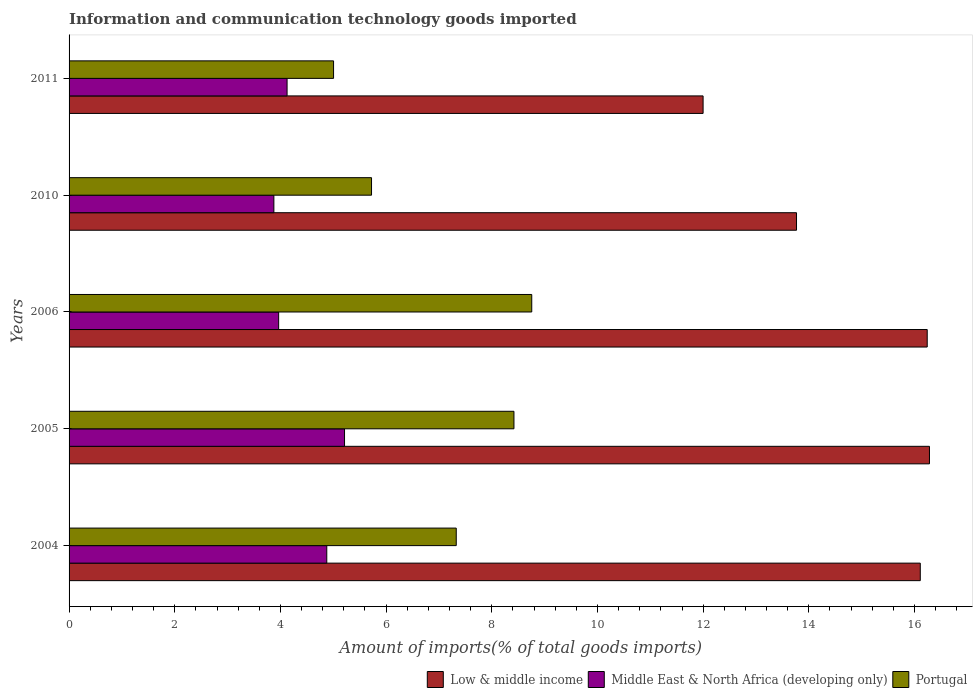How many bars are there on the 2nd tick from the top?
Your response must be concise. 3. In how many cases, is the number of bars for a given year not equal to the number of legend labels?
Your response must be concise. 0. What is the amount of goods imported in Middle East & North Africa (developing only) in 2010?
Provide a succinct answer. 3.88. Across all years, what is the maximum amount of goods imported in Middle East & North Africa (developing only)?
Your response must be concise. 5.21. Across all years, what is the minimum amount of goods imported in Portugal?
Provide a succinct answer. 5.01. In which year was the amount of goods imported in Low & middle income minimum?
Ensure brevity in your answer.  2011. What is the total amount of goods imported in Low & middle income in the graph?
Give a very brief answer. 74.4. What is the difference between the amount of goods imported in Low & middle income in 2010 and that in 2011?
Make the answer very short. 1.77. What is the difference between the amount of goods imported in Middle East & North Africa (developing only) in 2004 and the amount of goods imported in Portugal in 2005?
Keep it short and to the point. -3.54. What is the average amount of goods imported in Low & middle income per year?
Ensure brevity in your answer.  14.88. In the year 2005, what is the difference between the amount of goods imported in Middle East & North Africa (developing only) and amount of goods imported in Low & middle income?
Your response must be concise. -11.07. What is the ratio of the amount of goods imported in Middle East & North Africa (developing only) in 2004 to that in 2005?
Your answer should be compact. 0.94. Is the difference between the amount of goods imported in Middle East & North Africa (developing only) in 2006 and 2010 greater than the difference between the amount of goods imported in Low & middle income in 2006 and 2010?
Provide a succinct answer. No. What is the difference between the highest and the second highest amount of goods imported in Portugal?
Keep it short and to the point. 0.34. What is the difference between the highest and the lowest amount of goods imported in Low & middle income?
Your response must be concise. 4.28. In how many years, is the amount of goods imported in Low & middle income greater than the average amount of goods imported in Low & middle income taken over all years?
Offer a terse response. 3. Is the sum of the amount of goods imported in Portugal in 2004 and 2011 greater than the maximum amount of goods imported in Middle East & North Africa (developing only) across all years?
Make the answer very short. Yes. What does the 3rd bar from the top in 2005 represents?
Your answer should be very brief. Low & middle income. What does the 2nd bar from the bottom in 2010 represents?
Your answer should be very brief. Middle East & North Africa (developing only). How many bars are there?
Give a very brief answer. 15. What is the difference between two consecutive major ticks on the X-axis?
Your response must be concise. 2. Does the graph contain any zero values?
Offer a very short reply. No. How many legend labels are there?
Provide a short and direct response. 3. What is the title of the graph?
Your response must be concise. Information and communication technology goods imported. Does "Channel Islands" appear as one of the legend labels in the graph?
Keep it short and to the point. No. What is the label or title of the X-axis?
Keep it short and to the point. Amount of imports(% of total goods imports). What is the label or title of the Y-axis?
Ensure brevity in your answer.  Years. What is the Amount of imports(% of total goods imports) of Low & middle income in 2004?
Provide a succinct answer. 16.11. What is the Amount of imports(% of total goods imports) in Middle East & North Africa (developing only) in 2004?
Offer a very short reply. 4.88. What is the Amount of imports(% of total goods imports) of Portugal in 2004?
Give a very brief answer. 7.33. What is the Amount of imports(% of total goods imports) in Low & middle income in 2005?
Offer a terse response. 16.28. What is the Amount of imports(% of total goods imports) in Middle East & North Africa (developing only) in 2005?
Your answer should be compact. 5.21. What is the Amount of imports(% of total goods imports) in Portugal in 2005?
Your answer should be very brief. 8.42. What is the Amount of imports(% of total goods imports) in Low & middle income in 2006?
Your response must be concise. 16.24. What is the Amount of imports(% of total goods imports) in Middle East & North Africa (developing only) in 2006?
Offer a very short reply. 3.97. What is the Amount of imports(% of total goods imports) of Portugal in 2006?
Offer a very short reply. 8.76. What is the Amount of imports(% of total goods imports) in Low & middle income in 2010?
Your answer should be very brief. 13.77. What is the Amount of imports(% of total goods imports) of Middle East & North Africa (developing only) in 2010?
Offer a very short reply. 3.88. What is the Amount of imports(% of total goods imports) in Portugal in 2010?
Your answer should be compact. 5.72. What is the Amount of imports(% of total goods imports) in Low & middle income in 2011?
Keep it short and to the point. 12. What is the Amount of imports(% of total goods imports) in Middle East & North Africa (developing only) in 2011?
Keep it short and to the point. 4.13. What is the Amount of imports(% of total goods imports) of Portugal in 2011?
Give a very brief answer. 5.01. Across all years, what is the maximum Amount of imports(% of total goods imports) of Low & middle income?
Your response must be concise. 16.28. Across all years, what is the maximum Amount of imports(% of total goods imports) of Middle East & North Africa (developing only)?
Offer a terse response. 5.21. Across all years, what is the maximum Amount of imports(% of total goods imports) in Portugal?
Provide a short and direct response. 8.76. Across all years, what is the minimum Amount of imports(% of total goods imports) of Low & middle income?
Provide a short and direct response. 12. Across all years, what is the minimum Amount of imports(% of total goods imports) of Middle East & North Africa (developing only)?
Give a very brief answer. 3.88. Across all years, what is the minimum Amount of imports(% of total goods imports) in Portugal?
Provide a short and direct response. 5.01. What is the total Amount of imports(% of total goods imports) of Low & middle income in the graph?
Provide a short and direct response. 74.4. What is the total Amount of imports(% of total goods imports) in Middle East & North Africa (developing only) in the graph?
Provide a succinct answer. 22.06. What is the total Amount of imports(% of total goods imports) of Portugal in the graph?
Offer a very short reply. 35.23. What is the difference between the Amount of imports(% of total goods imports) of Low & middle income in 2004 and that in 2005?
Keep it short and to the point. -0.17. What is the difference between the Amount of imports(% of total goods imports) of Middle East & North Africa (developing only) in 2004 and that in 2005?
Keep it short and to the point. -0.34. What is the difference between the Amount of imports(% of total goods imports) of Portugal in 2004 and that in 2005?
Provide a short and direct response. -1.09. What is the difference between the Amount of imports(% of total goods imports) in Low & middle income in 2004 and that in 2006?
Offer a terse response. -0.13. What is the difference between the Amount of imports(% of total goods imports) in Middle East & North Africa (developing only) in 2004 and that in 2006?
Give a very brief answer. 0.91. What is the difference between the Amount of imports(% of total goods imports) of Portugal in 2004 and that in 2006?
Provide a short and direct response. -1.43. What is the difference between the Amount of imports(% of total goods imports) in Low & middle income in 2004 and that in 2010?
Keep it short and to the point. 2.34. What is the difference between the Amount of imports(% of total goods imports) in Middle East & North Africa (developing only) in 2004 and that in 2010?
Give a very brief answer. 1. What is the difference between the Amount of imports(% of total goods imports) of Portugal in 2004 and that in 2010?
Ensure brevity in your answer.  1.6. What is the difference between the Amount of imports(% of total goods imports) in Low & middle income in 2004 and that in 2011?
Give a very brief answer. 4.11. What is the difference between the Amount of imports(% of total goods imports) of Middle East & North Africa (developing only) in 2004 and that in 2011?
Offer a very short reply. 0.75. What is the difference between the Amount of imports(% of total goods imports) of Portugal in 2004 and that in 2011?
Offer a very short reply. 2.32. What is the difference between the Amount of imports(% of total goods imports) of Low & middle income in 2005 and that in 2006?
Make the answer very short. 0.04. What is the difference between the Amount of imports(% of total goods imports) in Middle East & North Africa (developing only) in 2005 and that in 2006?
Provide a succinct answer. 1.25. What is the difference between the Amount of imports(% of total goods imports) in Portugal in 2005 and that in 2006?
Your answer should be very brief. -0.34. What is the difference between the Amount of imports(% of total goods imports) of Low & middle income in 2005 and that in 2010?
Your response must be concise. 2.52. What is the difference between the Amount of imports(% of total goods imports) in Middle East & North Africa (developing only) in 2005 and that in 2010?
Provide a succinct answer. 1.34. What is the difference between the Amount of imports(% of total goods imports) of Portugal in 2005 and that in 2010?
Your answer should be compact. 2.7. What is the difference between the Amount of imports(% of total goods imports) of Low & middle income in 2005 and that in 2011?
Provide a succinct answer. 4.28. What is the difference between the Amount of imports(% of total goods imports) in Middle East & North Africa (developing only) in 2005 and that in 2011?
Provide a short and direct response. 1.09. What is the difference between the Amount of imports(% of total goods imports) in Portugal in 2005 and that in 2011?
Your response must be concise. 3.41. What is the difference between the Amount of imports(% of total goods imports) of Low & middle income in 2006 and that in 2010?
Your response must be concise. 2.47. What is the difference between the Amount of imports(% of total goods imports) in Middle East & North Africa (developing only) in 2006 and that in 2010?
Make the answer very short. 0.09. What is the difference between the Amount of imports(% of total goods imports) in Portugal in 2006 and that in 2010?
Your answer should be compact. 3.03. What is the difference between the Amount of imports(% of total goods imports) in Low & middle income in 2006 and that in 2011?
Ensure brevity in your answer.  4.24. What is the difference between the Amount of imports(% of total goods imports) of Middle East & North Africa (developing only) in 2006 and that in 2011?
Provide a succinct answer. -0.16. What is the difference between the Amount of imports(% of total goods imports) in Portugal in 2006 and that in 2011?
Offer a very short reply. 3.75. What is the difference between the Amount of imports(% of total goods imports) of Low & middle income in 2010 and that in 2011?
Make the answer very short. 1.77. What is the difference between the Amount of imports(% of total goods imports) of Middle East & North Africa (developing only) in 2010 and that in 2011?
Your answer should be compact. -0.25. What is the difference between the Amount of imports(% of total goods imports) of Portugal in 2010 and that in 2011?
Provide a succinct answer. 0.72. What is the difference between the Amount of imports(% of total goods imports) of Low & middle income in 2004 and the Amount of imports(% of total goods imports) of Middle East & North Africa (developing only) in 2005?
Your answer should be very brief. 10.9. What is the difference between the Amount of imports(% of total goods imports) in Low & middle income in 2004 and the Amount of imports(% of total goods imports) in Portugal in 2005?
Give a very brief answer. 7.69. What is the difference between the Amount of imports(% of total goods imports) in Middle East & North Africa (developing only) in 2004 and the Amount of imports(% of total goods imports) in Portugal in 2005?
Your answer should be very brief. -3.54. What is the difference between the Amount of imports(% of total goods imports) of Low & middle income in 2004 and the Amount of imports(% of total goods imports) of Middle East & North Africa (developing only) in 2006?
Keep it short and to the point. 12.14. What is the difference between the Amount of imports(% of total goods imports) in Low & middle income in 2004 and the Amount of imports(% of total goods imports) in Portugal in 2006?
Your response must be concise. 7.35. What is the difference between the Amount of imports(% of total goods imports) of Middle East & North Africa (developing only) in 2004 and the Amount of imports(% of total goods imports) of Portugal in 2006?
Give a very brief answer. -3.88. What is the difference between the Amount of imports(% of total goods imports) in Low & middle income in 2004 and the Amount of imports(% of total goods imports) in Middle East & North Africa (developing only) in 2010?
Offer a terse response. 12.23. What is the difference between the Amount of imports(% of total goods imports) of Low & middle income in 2004 and the Amount of imports(% of total goods imports) of Portugal in 2010?
Your response must be concise. 10.39. What is the difference between the Amount of imports(% of total goods imports) of Middle East & North Africa (developing only) in 2004 and the Amount of imports(% of total goods imports) of Portugal in 2010?
Ensure brevity in your answer.  -0.85. What is the difference between the Amount of imports(% of total goods imports) of Low & middle income in 2004 and the Amount of imports(% of total goods imports) of Middle East & North Africa (developing only) in 2011?
Your answer should be compact. 11.98. What is the difference between the Amount of imports(% of total goods imports) in Low & middle income in 2004 and the Amount of imports(% of total goods imports) in Portugal in 2011?
Your answer should be very brief. 11.1. What is the difference between the Amount of imports(% of total goods imports) in Middle East & North Africa (developing only) in 2004 and the Amount of imports(% of total goods imports) in Portugal in 2011?
Your response must be concise. -0.13. What is the difference between the Amount of imports(% of total goods imports) in Low & middle income in 2005 and the Amount of imports(% of total goods imports) in Middle East & North Africa (developing only) in 2006?
Your answer should be compact. 12.32. What is the difference between the Amount of imports(% of total goods imports) in Low & middle income in 2005 and the Amount of imports(% of total goods imports) in Portugal in 2006?
Offer a terse response. 7.53. What is the difference between the Amount of imports(% of total goods imports) of Middle East & North Africa (developing only) in 2005 and the Amount of imports(% of total goods imports) of Portugal in 2006?
Offer a terse response. -3.54. What is the difference between the Amount of imports(% of total goods imports) of Low & middle income in 2005 and the Amount of imports(% of total goods imports) of Middle East & North Africa (developing only) in 2010?
Offer a very short reply. 12.41. What is the difference between the Amount of imports(% of total goods imports) of Low & middle income in 2005 and the Amount of imports(% of total goods imports) of Portugal in 2010?
Ensure brevity in your answer.  10.56. What is the difference between the Amount of imports(% of total goods imports) in Middle East & North Africa (developing only) in 2005 and the Amount of imports(% of total goods imports) in Portugal in 2010?
Your response must be concise. -0.51. What is the difference between the Amount of imports(% of total goods imports) in Low & middle income in 2005 and the Amount of imports(% of total goods imports) in Middle East & North Africa (developing only) in 2011?
Offer a very short reply. 12.16. What is the difference between the Amount of imports(% of total goods imports) in Low & middle income in 2005 and the Amount of imports(% of total goods imports) in Portugal in 2011?
Offer a terse response. 11.28. What is the difference between the Amount of imports(% of total goods imports) in Middle East & North Africa (developing only) in 2005 and the Amount of imports(% of total goods imports) in Portugal in 2011?
Keep it short and to the point. 0.21. What is the difference between the Amount of imports(% of total goods imports) of Low & middle income in 2006 and the Amount of imports(% of total goods imports) of Middle East & North Africa (developing only) in 2010?
Give a very brief answer. 12.36. What is the difference between the Amount of imports(% of total goods imports) of Low & middle income in 2006 and the Amount of imports(% of total goods imports) of Portugal in 2010?
Give a very brief answer. 10.52. What is the difference between the Amount of imports(% of total goods imports) of Middle East & North Africa (developing only) in 2006 and the Amount of imports(% of total goods imports) of Portugal in 2010?
Your answer should be very brief. -1.76. What is the difference between the Amount of imports(% of total goods imports) in Low & middle income in 2006 and the Amount of imports(% of total goods imports) in Middle East & North Africa (developing only) in 2011?
Provide a succinct answer. 12.12. What is the difference between the Amount of imports(% of total goods imports) of Low & middle income in 2006 and the Amount of imports(% of total goods imports) of Portugal in 2011?
Give a very brief answer. 11.24. What is the difference between the Amount of imports(% of total goods imports) of Middle East & North Africa (developing only) in 2006 and the Amount of imports(% of total goods imports) of Portugal in 2011?
Provide a short and direct response. -1.04. What is the difference between the Amount of imports(% of total goods imports) in Low & middle income in 2010 and the Amount of imports(% of total goods imports) in Middle East & North Africa (developing only) in 2011?
Provide a succinct answer. 9.64. What is the difference between the Amount of imports(% of total goods imports) in Low & middle income in 2010 and the Amount of imports(% of total goods imports) in Portugal in 2011?
Offer a very short reply. 8.76. What is the difference between the Amount of imports(% of total goods imports) of Middle East & North Africa (developing only) in 2010 and the Amount of imports(% of total goods imports) of Portugal in 2011?
Provide a succinct answer. -1.13. What is the average Amount of imports(% of total goods imports) of Low & middle income per year?
Offer a terse response. 14.88. What is the average Amount of imports(% of total goods imports) in Middle East & North Africa (developing only) per year?
Keep it short and to the point. 4.41. What is the average Amount of imports(% of total goods imports) in Portugal per year?
Keep it short and to the point. 7.05. In the year 2004, what is the difference between the Amount of imports(% of total goods imports) in Low & middle income and Amount of imports(% of total goods imports) in Middle East & North Africa (developing only)?
Ensure brevity in your answer.  11.23. In the year 2004, what is the difference between the Amount of imports(% of total goods imports) in Low & middle income and Amount of imports(% of total goods imports) in Portugal?
Your response must be concise. 8.78. In the year 2004, what is the difference between the Amount of imports(% of total goods imports) of Middle East & North Africa (developing only) and Amount of imports(% of total goods imports) of Portugal?
Your answer should be compact. -2.45. In the year 2005, what is the difference between the Amount of imports(% of total goods imports) in Low & middle income and Amount of imports(% of total goods imports) in Middle East & North Africa (developing only)?
Give a very brief answer. 11.07. In the year 2005, what is the difference between the Amount of imports(% of total goods imports) of Low & middle income and Amount of imports(% of total goods imports) of Portugal?
Keep it short and to the point. 7.86. In the year 2005, what is the difference between the Amount of imports(% of total goods imports) of Middle East & North Africa (developing only) and Amount of imports(% of total goods imports) of Portugal?
Give a very brief answer. -3.21. In the year 2006, what is the difference between the Amount of imports(% of total goods imports) of Low & middle income and Amount of imports(% of total goods imports) of Middle East & North Africa (developing only)?
Provide a succinct answer. 12.27. In the year 2006, what is the difference between the Amount of imports(% of total goods imports) of Low & middle income and Amount of imports(% of total goods imports) of Portugal?
Provide a short and direct response. 7.48. In the year 2006, what is the difference between the Amount of imports(% of total goods imports) of Middle East & North Africa (developing only) and Amount of imports(% of total goods imports) of Portugal?
Your response must be concise. -4.79. In the year 2010, what is the difference between the Amount of imports(% of total goods imports) of Low & middle income and Amount of imports(% of total goods imports) of Middle East & North Africa (developing only)?
Make the answer very short. 9.89. In the year 2010, what is the difference between the Amount of imports(% of total goods imports) in Low & middle income and Amount of imports(% of total goods imports) in Portugal?
Give a very brief answer. 8.04. In the year 2010, what is the difference between the Amount of imports(% of total goods imports) in Middle East & North Africa (developing only) and Amount of imports(% of total goods imports) in Portugal?
Provide a succinct answer. -1.85. In the year 2011, what is the difference between the Amount of imports(% of total goods imports) of Low & middle income and Amount of imports(% of total goods imports) of Middle East & North Africa (developing only)?
Your answer should be very brief. 7.87. In the year 2011, what is the difference between the Amount of imports(% of total goods imports) in Low & middle income and Amount of imports(% of total goods imports) in Portugal?
Ensure brevity in your answer.  6.99. In the year 2011, what is the difference between the Amount of imports(% of total goods imports) in Middle East & North Africa (developing only) and Amount of imports(% of total goods imports) in Portugal?
Keep it short and to the point. -0.88. What is the ratio of the Amount of imports(% of total goods imports) in Low & middle income in 2004 to that in 2005?
Ensure brevity in your answer.  0.99. What is the ratio of the Amount of imports(% of total goods imports) of Middle East & North Africa (developing only) in 2004 to that in 2005?
Provide a short and direct response. 0.94. What is the ratio of the Amount of imports(% of total goods imports) in Portugal in 2004 to that in 2005?
Give a very brief answer. 0.87. What is the ratio of the Amount of imports(% of total goods imports) of Low & middle income in 2004 to that in 2006?
Give a very brief answer. 0.99. What is the ratio of the Amount of imports(% of total goods imports) in Middle East & North Africa (developing only) in 2004 to that in 2006?
Keep it short and to the point. 1.23. What is the ratio of the Amount of imports(% of total goods imports) in Portugal in 2004 to that in 2006?
Make the answer very short. 0.84. What is the ratio of the Amount of imports(% of total goods imports) in Low & middle income in 2004 to that in 2010?
Offer a very short reply. 1.17. What is the ratio of the Amount of imports(% of total goods imports) in Middle East & North Africa (developing only) in 2004 to that in 2010?
Offer a very short reply. 1.26. What is the ratio of the Amount of imports(% of total goods imports) of Portugal in 2004 to that in 2010?
Offer a terse response. 1.28. What is the ratio of the Amount of imports(% of total goods imports) in Low & middle income in 2004 to that in 2011?
Your answer should be compact. 1.34. What is the ratio of the Amount of imports(% of total goods imports) in Middle East & North Africa (developing only) in 2004 to that in 2011?
Your response must be concise. 1.18. What is the ratio of the Amount of imports(% of total goods imports) in Portugal in 2004 to that in 2011?
Make the answer very short. 1.46. What is the ratio of the Amount of imports(% of total goods imports) of Middle East & North Africa (developing only) in 2005 to that in 2006?
Your answer should be very brief. 1.31. What is the ratio of the Amount of imports(% of total goods imports) in Portugal in 2005 to that in 2006?
Provide a succinct answer. 0.96. What is the ratio of the Amount of imports(% of total goods imports) in Low & middle income in 2005 to that in 2010?
Give a very brief answer. 1.18. What is the ratio of the Amount of imports(% of total goods imports) in Middle East & North Africa (developing only) in 2005 to that in 2010?
Keep it short and to the point. 1.34. What is the ratio of the Amount of imports(% of total goods imports) of Portugal in 2005 to that in 2010?
Your answer should be compact. 1.47. What is the ratio of the Amount of imports(% of total goods imports) in Low & middle income in 2005 to that in 2011?
Provide a short and direct response. 1.36. What is the ratio of the Amount of imports(% of total goods imports) of Middle East & North Africa (developing only) in 2005 to that in 2011?
Give a very brief answer. 1.26. What is the ratio of the Amount of imports(% of total goods imports) of Portugal in 2005 to that in 2011?
Provide a succinct answer. 1.68. What is the ratio of the Amount of imports(% of total goods imports) of Low & middle income in 2006 to that in 2010?
Provide a succinct answer. 1.18. What is the ratio of the Amount of imports(% of total goods imports) in Middle East & North Africa (developing only) in 2006 to that in 2010?
Your answer should be compact. 1.02. What is the ratio of the Amount of imports(% of total goods imports) of Portugal in 2006 to that in 2010?
Offer a very short reply. 1.53. What is the ratio of the Amount of imports(% of total goods imports) in Low & middle income in 2006 to that in 2011?
Ensure brevity in your answer.  1.35. What is the ratio of the Amount of imports(% of total goods imports) in Middle East & North Africa (developing only) in 2006 to that in 2011?
Your answer should be compact. 0.96. What is the ratio of the Amount of imports(% of total goods imports) of Portugal in 2006 to that in 2011?
Your answer should be very brief. 1.75. What is the ratio of the Amount of imports(% of total goods imports) of Low & middle income in 2010 to that in 2011?
Your answer should be very brief. 1.15. What is the ratio of the Amount of imports(% of total goods imports) of Middle East & North Africa (developing only) in 2010 to that in 2011?
Offer a terse response. 0.94. What is the ratio of the Amount of imports(% of total goods imports) of Portugal in 2010 to that in 2011?
Offer a very short reply. 1.14. What is the difference between the highest and the second highest Amount of imports(% of total goods imports) of Low & middle income?
Your answer should be very brief. 0.04. What is the difference between the highest and the second highest Amount of imports(% of total goods imports) in Middle East & North Africa (developing only)?
Offer a terse response. 0.34. What is the difference between the highest and the second highest Amount of imports(% of total goods imports) of Portugal?
Offer a very short reply. 0.34. What is the difference between the highest and the lowest Amount of imports(% of total goods imports) in Low & middle income?
Provide a short and direct response. 4.28. What is the difference between the highest and the lowest Amount of imports(% of total goods imports) in Middle East & North Africa (developing only)?
Provide a short and direct response. 1.34. What is the difference between the highest and the lowest Amount of imports(% of total goods imports) of Portugal?
Make the answer very short. 3.75. 